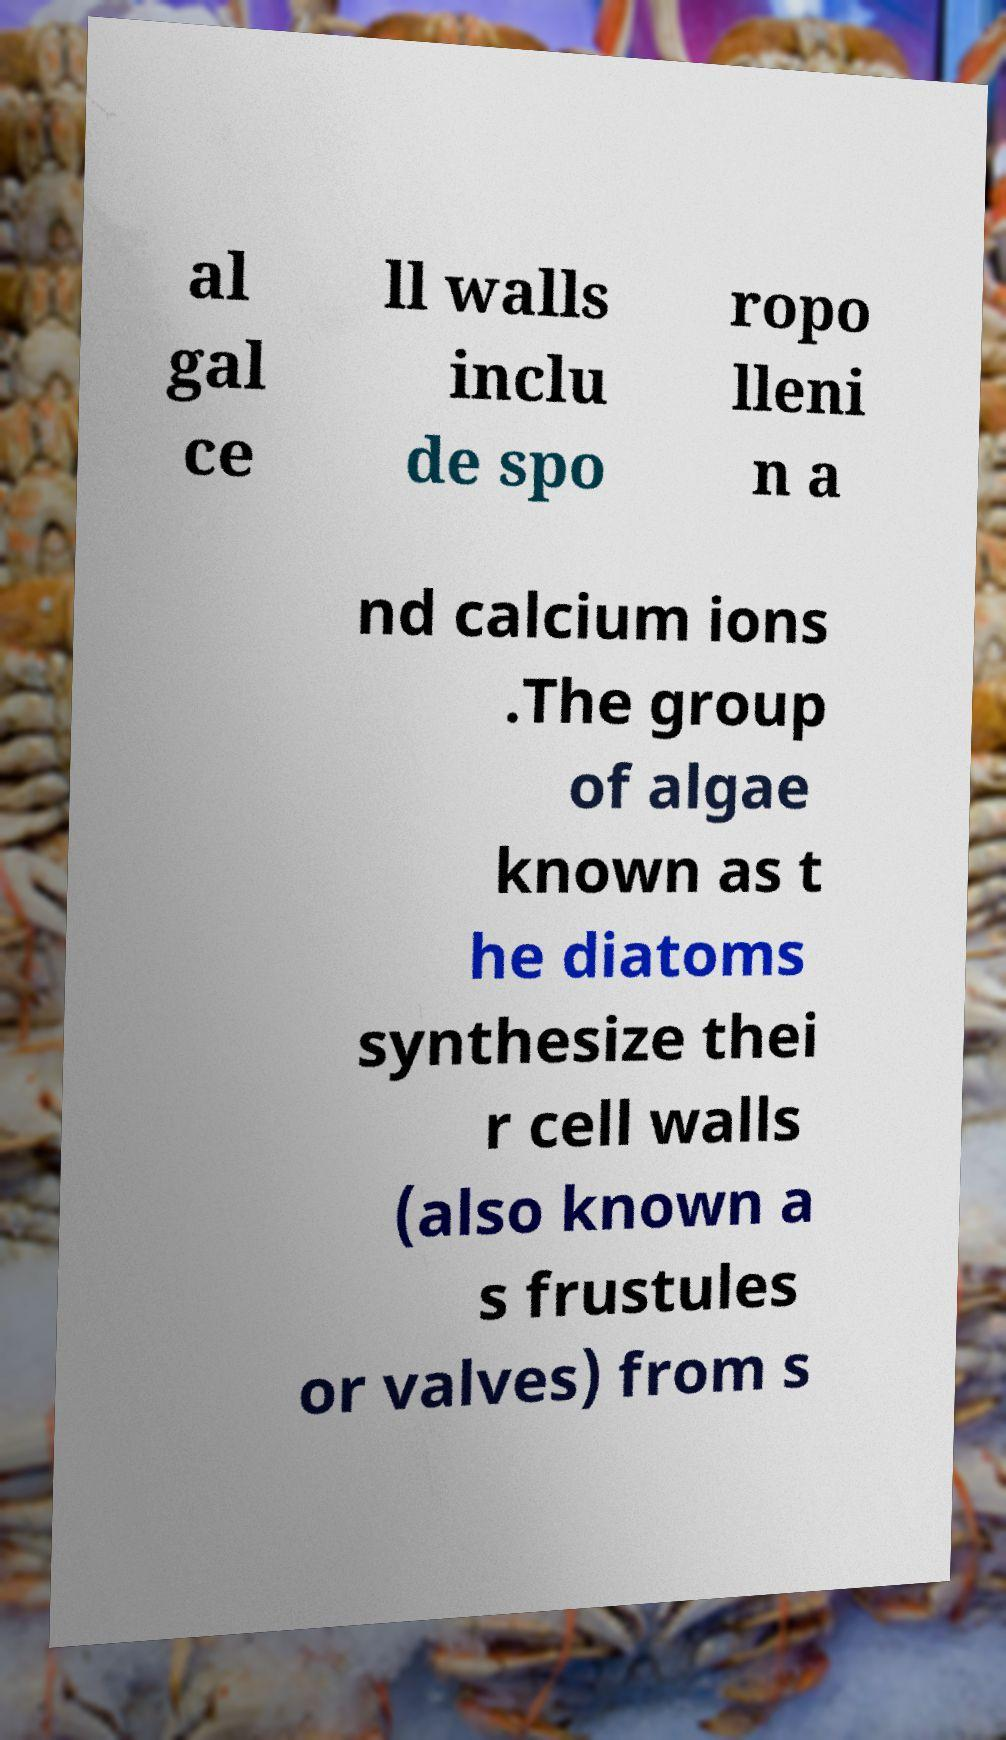Could you assist in decoding the text presented in this image and type it out clearly? al gal ce ll walls inclu de spo ropo lleni n a nd calcium ions .The group of algae known as t he diatoms synthesize thei r cell walls (also known a s frustules or valves) from s 